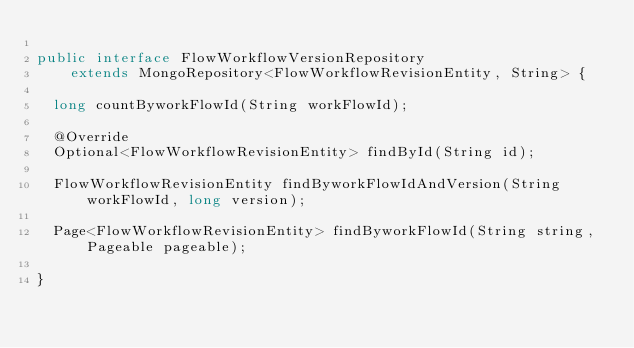Convert code to text. <code><loc_0><loc_0><loc_500><loc_500><_Java_>
public interface FlowWorkflowVersionRepository
    extends MongoRepository<FlowWorkflowRevisionEntity, String> {

  long countByworkFlowId(String workFlowId);

  @Override
  Optional<FlowWorkflowRevisionEntity> findById(String id);

  FlowWorkflowRevisionEntity findByworkFlowIdAndVersion(String workFlowId, long version);

  Page<FlowWorkflowRevisionEntity> findByworkFlowId(String string, Pageable pageable);

}
</code> 